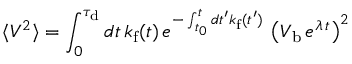<formula> <loc_0><loc_0><loc_500><loc_500>\langle V ^ { 2 } \rangle = \int _ { 0 } ^ { \tau _ { d } } d t \, k _ { f } ( t ) \, e ^ { - \int _ { t _ { 0 } } ^ { t } d t ^ { \prime } k _ { f } ( t ^ { \prime } ) } \, \left ( V _ { b } \, e ^ { \lambda \, t } \right ) ^ { 2 }</formula> 